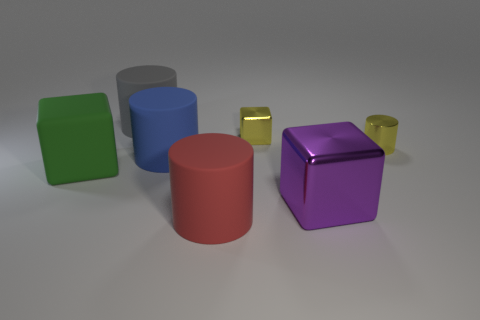Add 2 large cylinders. How many objects exist? 9 Subtract all cubes. How many objects are left? 4 Add 3 cyan blocks. How many cyan blocks exist? 3 Subtract 0 yellow balls. How many objects are left? 7 Subtract all tiny shiny cylinders. Subtract all matte cylinders. How many objects are left? 3 Add 5 tiny metallic blocks. How many tiny metallic blocks are left? 6 